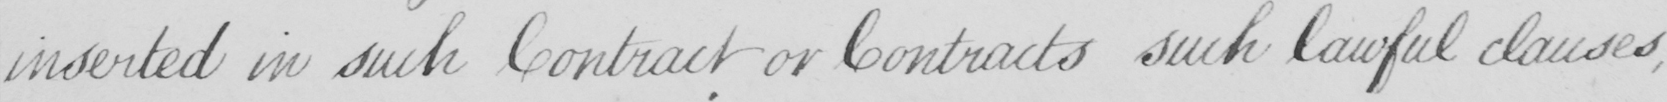Can you read and transcribe this handwriting? inserted in such Contract or Contracts such lawful clauses , 